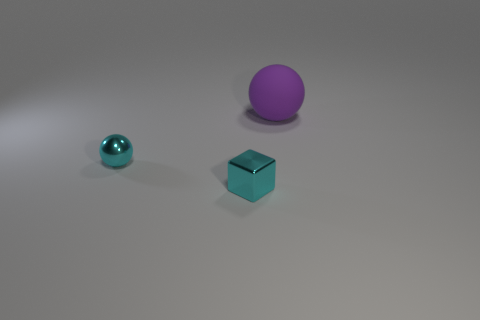Add 2 large matte objects. How many objects exist? 5 Subtract all balls. How many objects are left? 1 Subtract 0 brown cylinders. How many objects are left? 3 Subtract all big blue things. Subtract all large spheres. How many objects are left? 2 Add 3 metal cubes. How many metal cubes are left? 4 Add 3 cylinders. How many cylinders exist? 3 